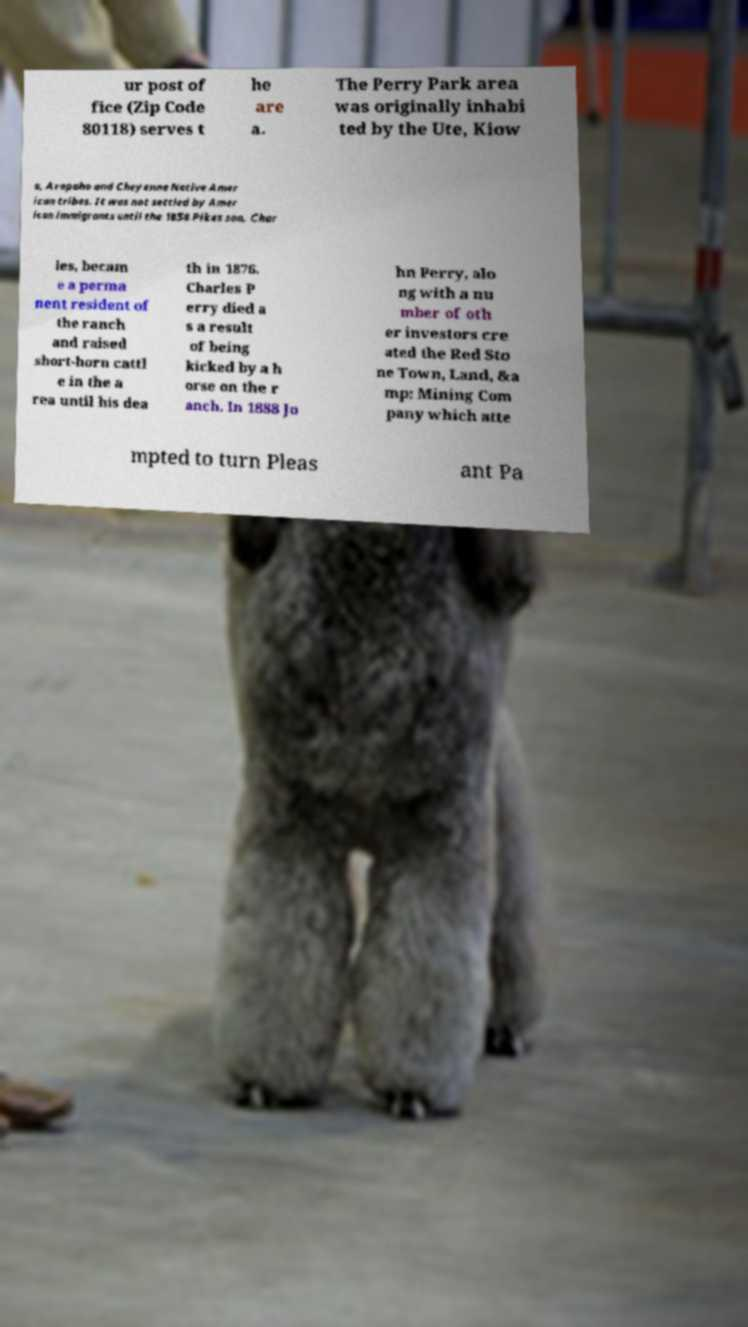There's text embedded in this image that I need extracted. Can you transcribe it verbatim? ur post of fice (Zip Code 80118) serves t he are a. The Perry Park area was originally inhabi ted by the Ute, Kiow a, Arapaho and Cheyenne Native Amer ican tribes. It was not settled by Amer ican immigrants until the 1858 Pikes son, Char les, becam e a perma nent resident of the ranch and raised short-horn cattl e in the a rea until his dea th in 1876. Charles P erry died a s a result of being kicked by a h orse on the r anch. In 1888 Jo hn Perry, alo ng with a nu mber of oth er investors cre ated the Red Sto ne Town, Land, &a mp; Mining Com pany which atte mpted to turn Pleas ant Pa 